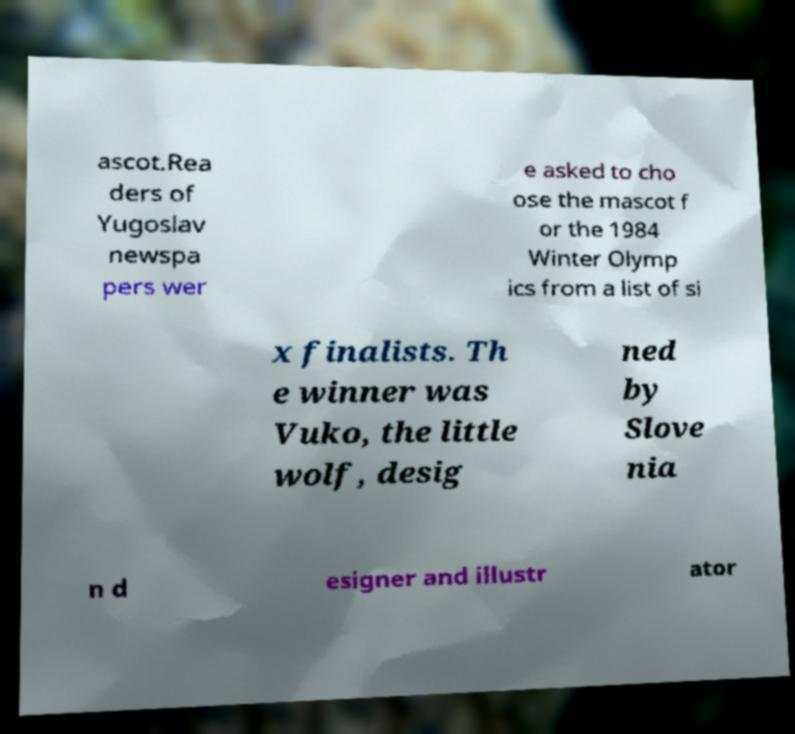Could you extract and type out the text from this image? ascot.Rea ders of Yugoslav newspa pers wer e asked to cho ose the mascot f or the 1984 Winter Olymp ics from a list of si x finalists. Th e winner was Vuko, the little wolf, desig ned by Slove nia n d esigner and illustr ator 